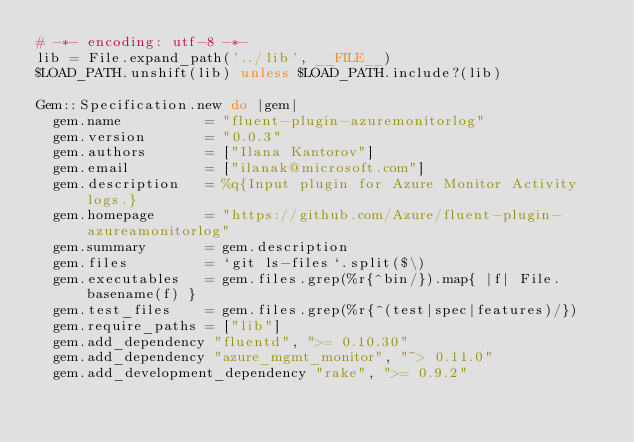Convert code to text. <code><loc_0><loc_0><loc_500><loc_500><_Ruby_># -*- encoding: utf-8 -*-
lib = File.expand_path('../lib', __FILE__)
$LOAD_PATH.unshift(lib) unless $LOAD_PATH.include?(lib)

Gem::Specification.new do |gem|
  gem.name          = "fluent-plugin-azuremonitorlog"
  gem.version       = "0.0.3"
  gem.authors       = ["Ilana Kantorov"]
  gem.email         = ["ilanak@microsoft.com"]
  gem.description   = %q{Input plugin for Azure Monitor Activity logs.}
  gem.homepage      = "https://github.com/Azure/fluent-plugin-azureamonitorlog"
  gem.summary       = gem.description
  gem.files         = `git ls-files`.split($\)
  gem.executables   = gem.files.grep(%r{^bin/}).map{ |f| File.basename(f) }
  gem.test_files    = gem.files.grep(%r{^(test|spec|features)/})
  gem.require_paths = ["lib"]
  gem.add_dependency "fluentd", ">= 0.10.30"
  gem.add_dependency "azure_mgmt_monitor", "~> 0.11.0"
  gem.add_development_dependency "rake", ">= 0.9.2"</code> 